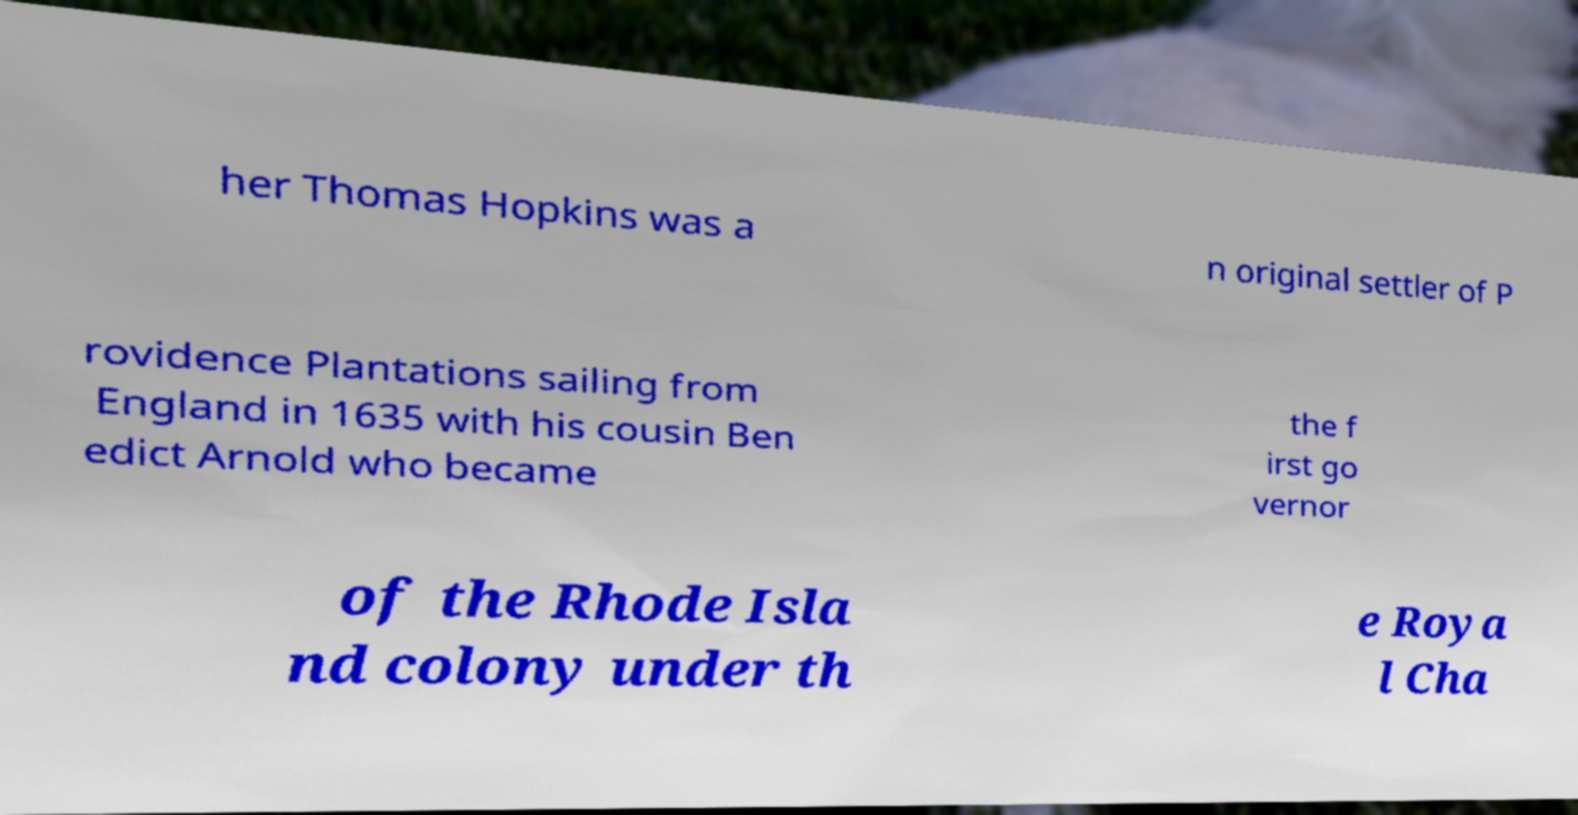For documentation purposes, I need the text within this image transcribed. Could you provide that? her Thomas Hopkins was a n original settler of P rovidence Plantations sailing from England in 1635 with his cousin Ben edict Arnold who became the f irst go vernor of the Rhode Isla nd colony under th e Roya l Cha 